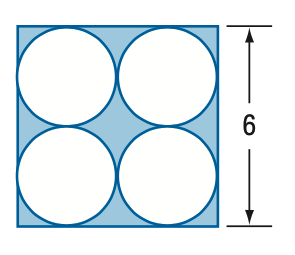Question: Find the area of the shaded region. Round to the nearest tenth.
Choices:
A. 7.1
B. 7.7
C. 21.9
D. 28.9
Answer with the letter. Answer: B 